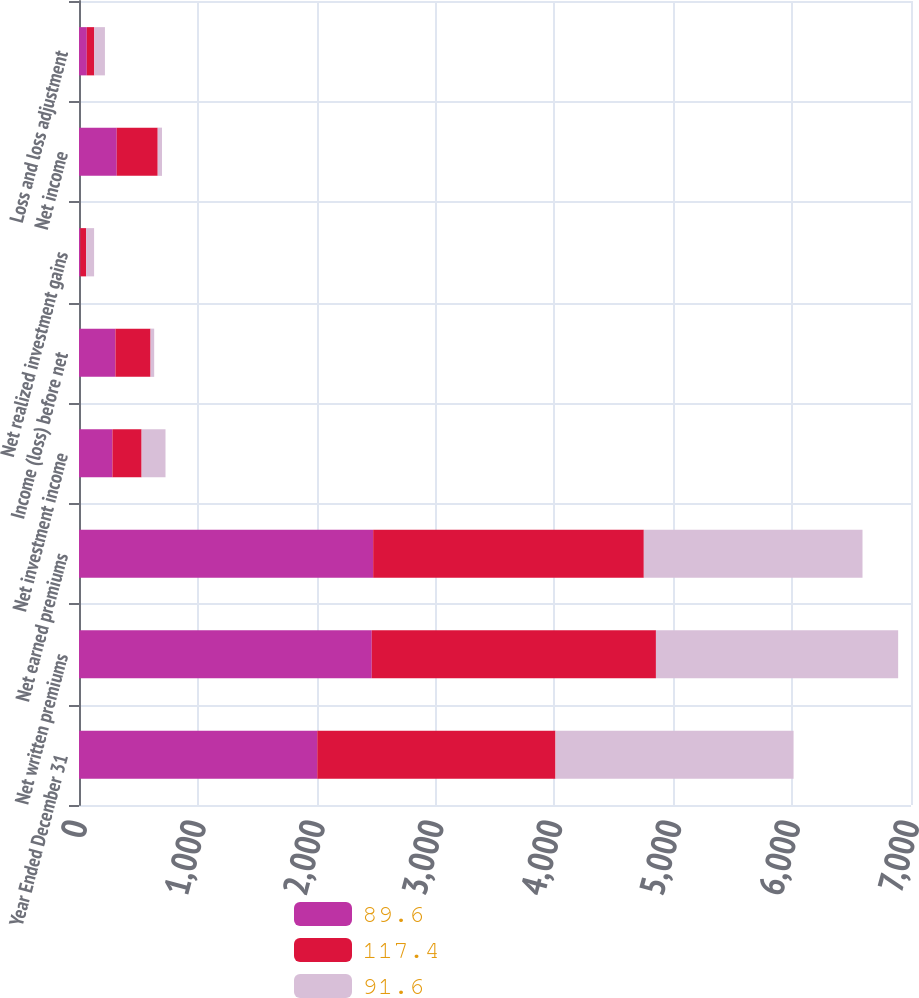<chart> <loc_0><loc_0><loc_500><loc_500><stacked_bar_chart><ecel><fcel>Year Ended December 31<fcel>Net written premiums<fcel>Net earned premiums<fcel>Net investment income<fcel>Income (loss) before net<fcel>Net realized investment gains<fcel>Net income<fcel>Loss and loss adjustment<nl><fcel>89.6<fcel>2005<fcel>2463<fcel>2475<fcel>281.3<fcel>306.7<fcel>10.7<fcel>317.4<fcel>65.3<nl><fcel>117.4<fcel>2004<fcel>2391<fcel>2277<fcel>245.5<fcel>295.3<fcel>49.6<fcel>344.9<fcel>63.3<nl><fcel>91.6<fcel>2003<fcel>2038<fcel>1840<fcel>201<fcel>30.6<fcel>66.7<fcel>36.1<fcel>89.6<nl></chart> 